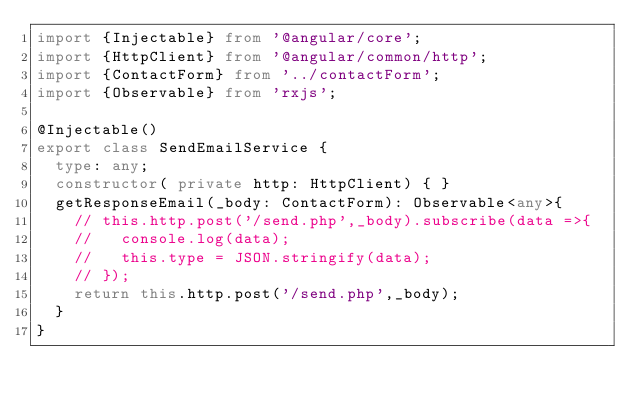Convert code to text. <code><loc_0><loc_0><loc_500><loc_500><_TypeScript_>import {Injectable} from '@angular/core';
import {HttpClient} from '@angular/common/http';
import {ContactForm} from '../contactForm';
import {Observable} from 'rxjs';

@Injectable()
export class SendEmailService {
  type: any;
  constructor( private http: HttpClient) { }
  getResponseEmail(_body: ContactForm): Observable<any>{
    // this.http.post('/send.php',_body).subscribe(data =>{
    //   console.log(data);
    //   this.type = JSON.stringify(data);
    // });
    return this.http.post('/send.php',_body);
  }
}
</code> 